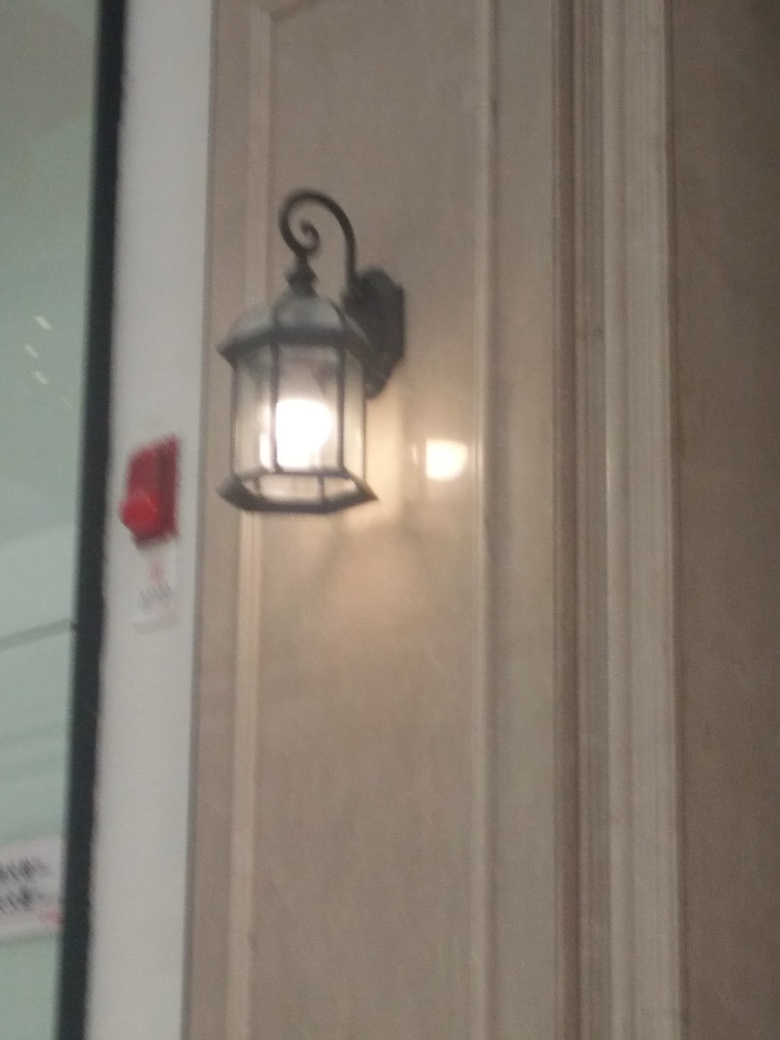What kind of mood or atmosphere does this lighting create? The warm, soft light emanating from the lamp provides a welcoming and cozy atmosphere. It creates an intimate ambiance that might make a space feel more relaxed and serene, perhaps suggesting an environment meant for tranquility or contemplation. 